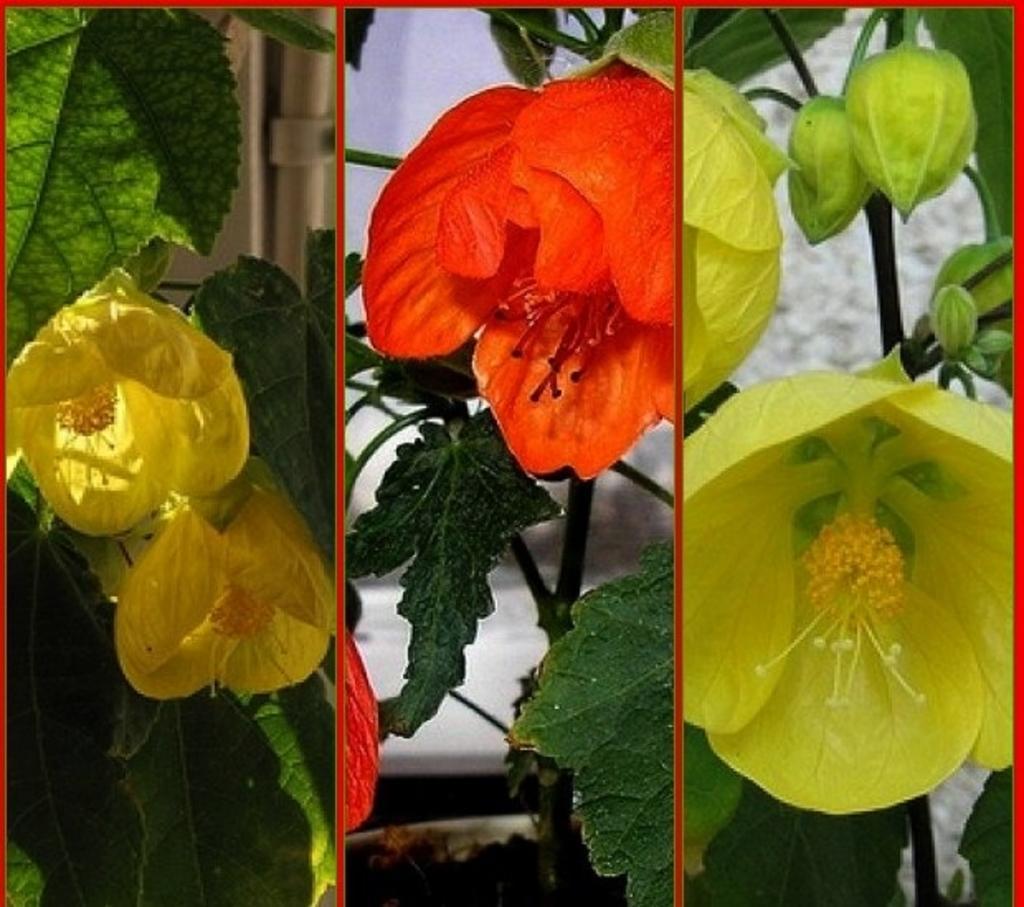Can you describe this image briefly? This picture is a collage of three images. I can observe three different colors of flowers in these three images. In the first picture I can observe yellow and in the second image I can observe red color flowers. In the third image I can observe green color flower. 